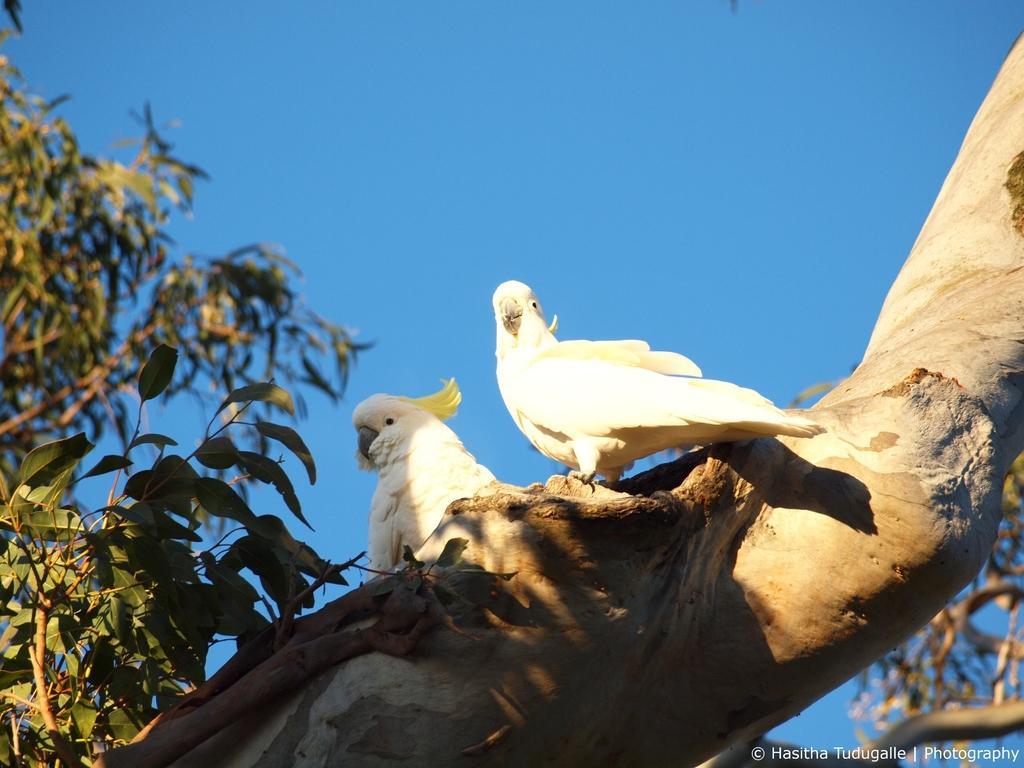Please provide a concise description of this image. In this image in the front there is a tree trunk and there are birds standing on the tree trunk. In the background there are leaves. 